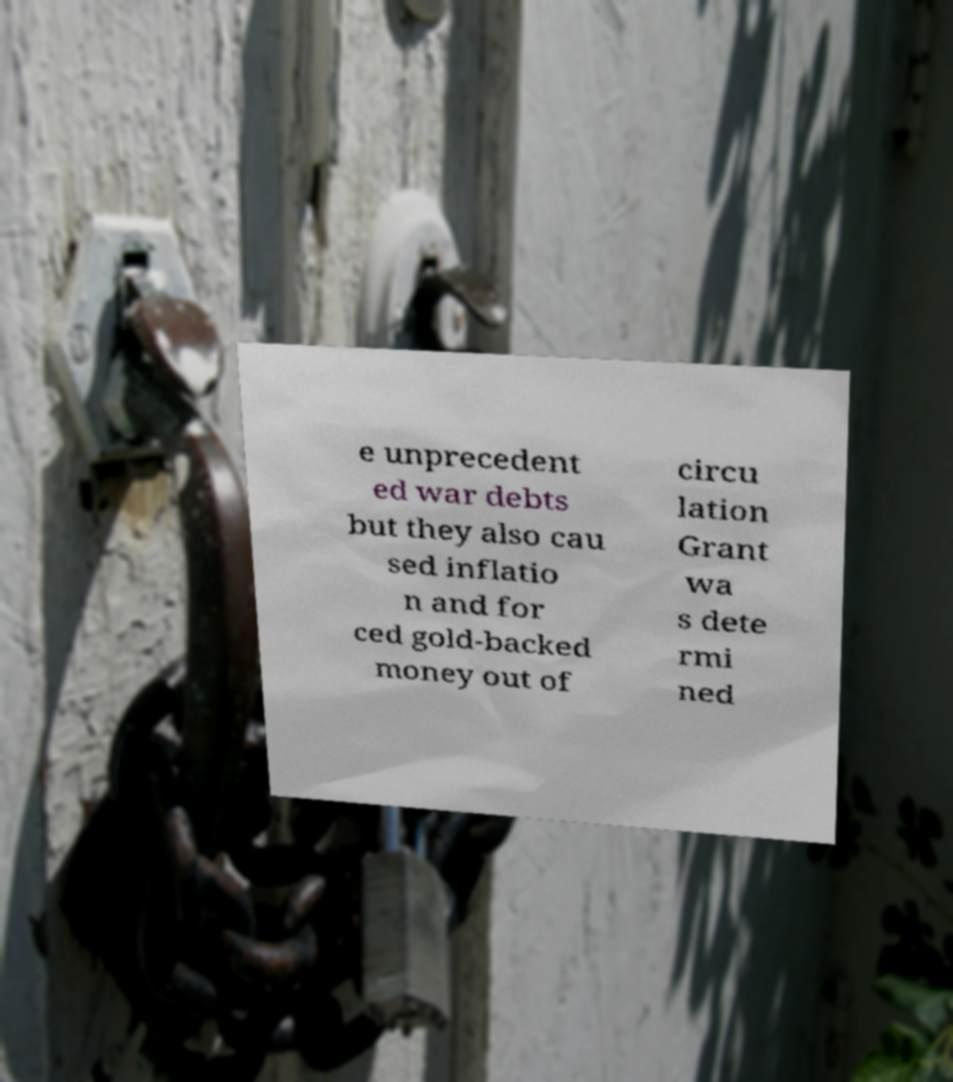There's text embedded in this image that I need extracted. Can you transcribe it verbatim? e unprecedent ed war debts but they also cau sed inflatio n and for ced gold-backed money out of circu lation Grant wa s dete rmi ned 